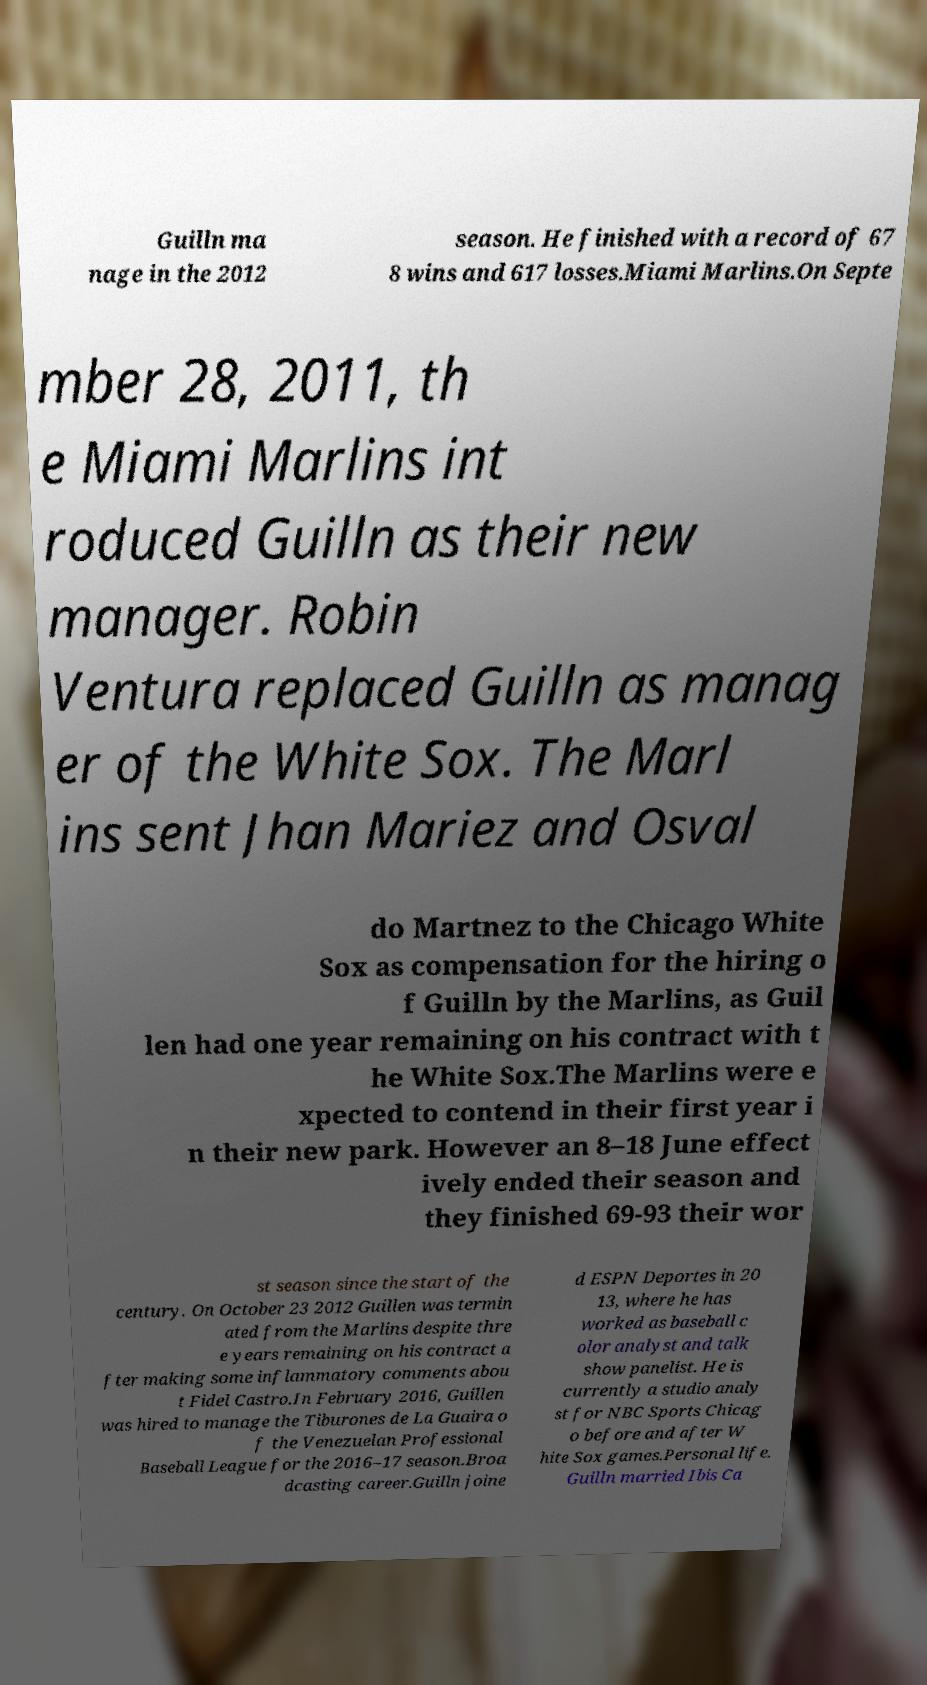Please identify and transcribe the text found in this image. Guilln ma nage in the 2012 season. He finished with a record of 67 8 wins and 617 losses.Miami Marlins.On Septe mber 28, 2011, th e Miami Marlins int roduced Guilln as their new manager. Robin Ventura replaced Guilln as manag er of the White Sox. The Marl ins sent Jhan Mariez and Osval do Martnez to the Chicago White Sox as compensation for the hiring o f Guilln by the Marlins, as Guil len had one year remaining on his contract with t he White Sox.The Marlins were e xpected to contend in their first year i n their new park. However an 8–18 June effect ively ended their season and they finished 69-93 their wor st season since the start of the century. On October 23 2012 Guillen was termin ated from the Marlins despite thre e years remaining on his contract a fter making some inflammatory comments abou t Fidel Castro.In February 2016, Guillen was hired to manage the Tiburones de La Guaira o f the Venezuelan Professional Baseball League for the 2016–17 season.Broa dcasting career.Guilln joine d ESPN Deportes in 20 13, where he has worked as baseball c olor analyst and talk show panelist. He is currently a studio analy st for NBC Sports Chicag o before and after W hite Sox games.Personal life. Guilln married Ibis Ca 